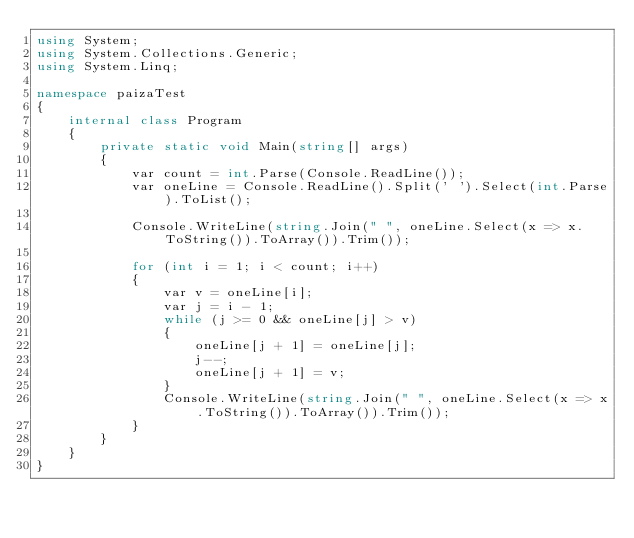<code> <loc_0><loc_0><loc_500><loc_500><_C#_>using System;
using System.Collections.Generic;
using System.Linq;

namespace paizaTest
{
    internal class Program
    {
        private static void Main(string[] args)
        {
            var count = int.Parse(Console.ReadLine());
            var oneLine = Console.ReadLine().Split(' ').Select(int.Parse).ToList();

            Console.WriteLine(string.Join(" ", oneLine.Select(x => x.ToString()).ToArray()).Trim());

            for (int i = 1; i < count; i++)
            {
                var v = oneLine[i];
                var j = i - 1;
                while (j >= 0 && oneLine[j] > v)
                {
                    oneLine[j + 1] = oneLine[j];
                    j--;
                    oneLine[j + 1] = v;
                }
                Console.WriteLine(string.Join(" ", oneLine.Select(x => x.ToString()).ToArray()).Trim());
            }
        }
    }
}</code> 